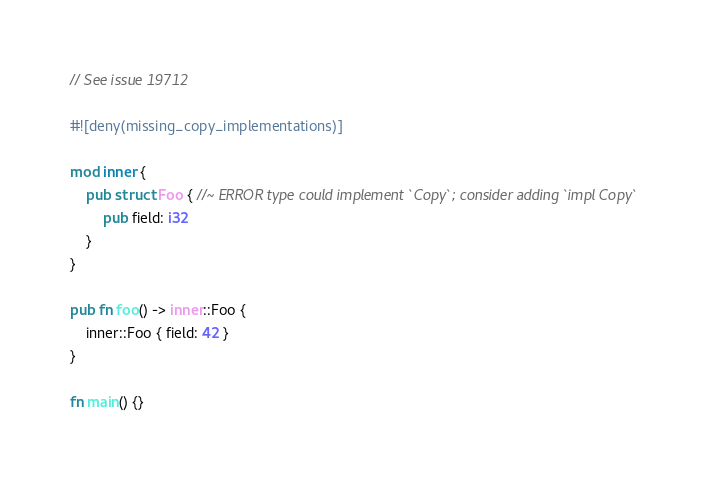Convert code to text. <code><loc_0><loc_0><loc_500><loc_500><_Rust_>// See issue 19712

#![deny(missing_copy_implementations)]

mod inner {
    pub struct Foo { //~ ERROR type could implement `Copy`; consider adding `impl Copy`
        pub field: i32
    }
}

pub fn foo() -> inner::Foo {
    inner::Foo { field: 42 }
}

fn main() {}
</code> 